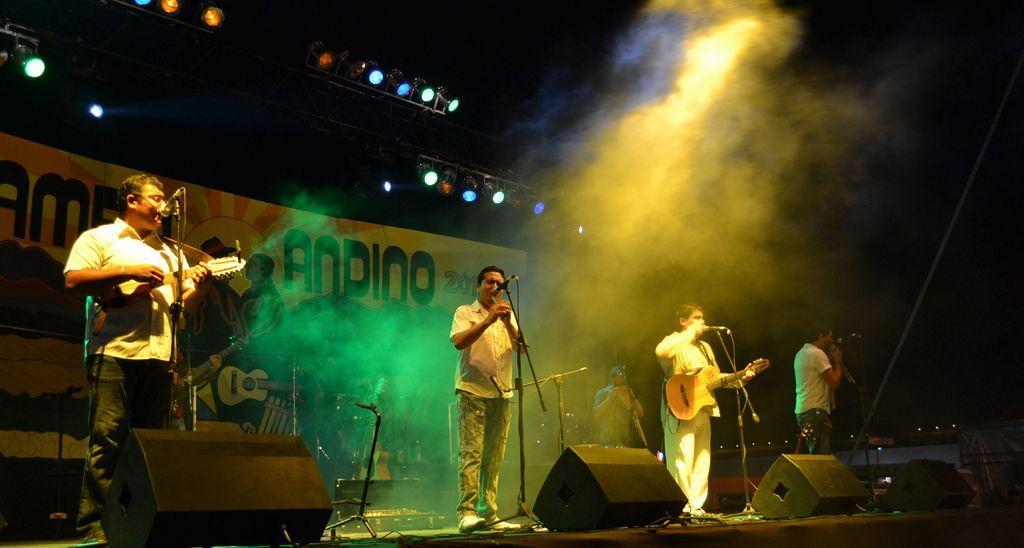Could you give a brief overview of what you see in this image? In this picture we can see five persons are standing on the stage. They are playing guitar. And he is singing on the mike. On the background we can see a banner. And these are the lights. 